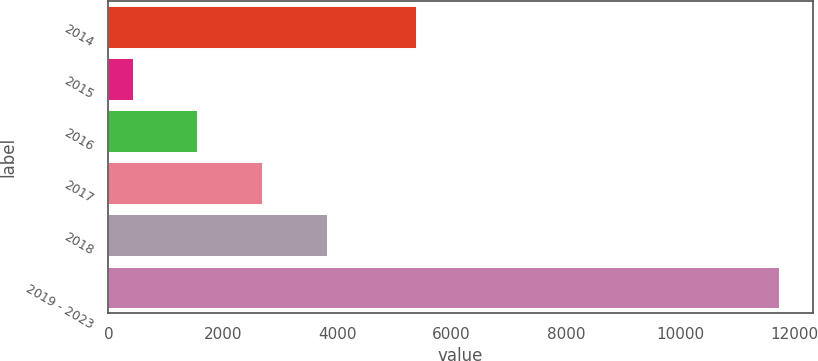Convert chart to OTSL. <chart><loc_0><loc_0><loc_500><loc_500><bar_chart><fcel>2014<fcel>2015<fcel>2016<fcel>2017<fcel>2018<fcel>2019 - 2023<nl><fcel>5372<fcel>426<fcel>1555.9<fcel>2685.8<fcel>3815.7<fcel>11725<nl></chart> 